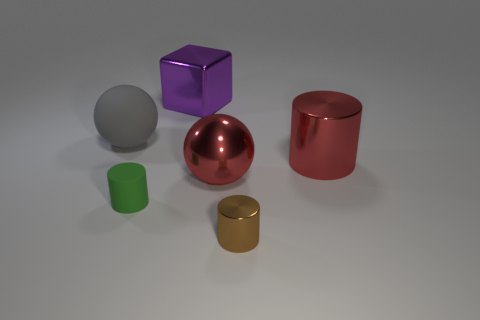Are there fewer brown cylinders that are left of the small green matte cylinder than brown things behind the brown shiny cylinder?
Your response must be concise. No. How many other large cylinders have the same material as the brown cylinder?
Your answer should be very brief. 1. There is a matte thing that is in front of the large ball that is to the left of the big purple cube; is there a big metallic cylinder that is to the left of it?
Provide a succinct answer. No. How many balls are either large matte things or big objects?
Provide a short and direct response. 2. Do the purple object and the tiny thing that is on the right side of the purple cube have the same shape?
Keep it short and to the point. No. Is the number of small rubber cylinders behind the large purple shiny object less than the number of blue balls?
Provide a succinct answer. No. There is a big metallic cube; are there any large blocks behind it?
Your response must be concise. No. Are there any big metallic objects of the same shape as the small brown metallic object?
Offer a terse response. Yes. There is a purple metal object that is the same size as the gray thing; what shape is it?
Offer a very short reply. Cube. How many things are either large things right of the tiny brown metal cylinder or large red metallic spheres?
Provide a short and direct response. 2. 